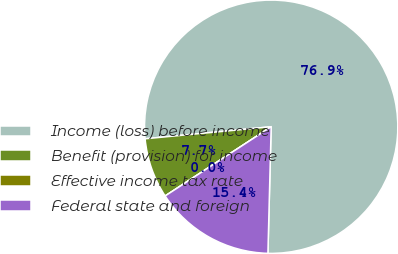Convert chart. <chart><loc_0><loc_0><loc_500><loc_500><pie_chart><fcel>Income (loss) before income<fcel>Benefit (provision) for income<fcel>Effective income tax rate<fcel>Federal state and foreign<nl><fcel>76.92%<fcel>7.69%<fcel>0.0%<fcel>15.38%<nl></chart> 